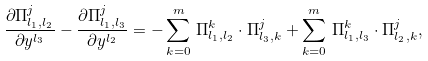<formula> <loc_0><loc_0><loc_500><loc_500>\frac { \partial \Pi _ { l _ { 1 } , l _ { 2 } } ^ { j } } { \partial y ^ { l _ { 3 } } } - \frac { \partial \Pi _ { l _ { 1 } , l _ { 3 } } ^ { j } } { \partial y ^ { l _ { 2 } } } = - \sum _ { k = 0 } ^ { m } \, \Pi _ { l _ { 1 } , l _ { 2 } } ^ { k } \cdot \Pi _ { l _ { 3 } , k } ^ { j } + \sum _ { k = 0 } ^ { m } \, \Pi _ { l _ { 1 } , l _ { 3 } } ^ { k } \cdot \Pi _ { l _ { 2 } , k } ^ { j } ,</formula> 